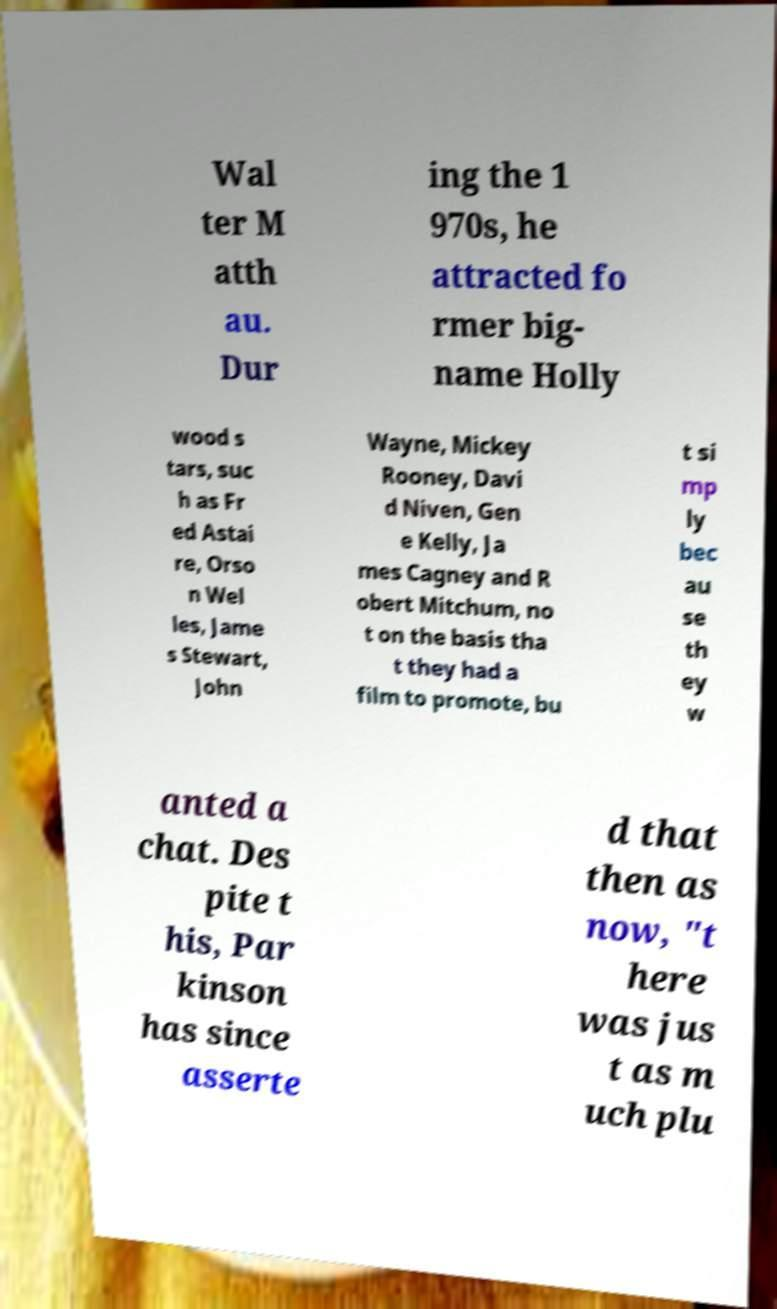What messages or text are displayed in this image? I need them in a readable, typed format. Wal ter M atth au. Dur ing the 1 970s, he attracted fo rmer big- name Holly wood s tars, suc h as Fr ed Astai re, Orso n Wel les, Jame s Stewart, John Wayne, Mickey Rooney, Davi d Niven, Gen e Kelly, Ja mes Cagney and R obert Mitchum, no t on the basis tha t they had a film to promote, bu t si mp ly bec au se th ey w anted a chat. Des pite t his, Par kinson has since asserte d that then as now, "t here was jus t as m uch plu 